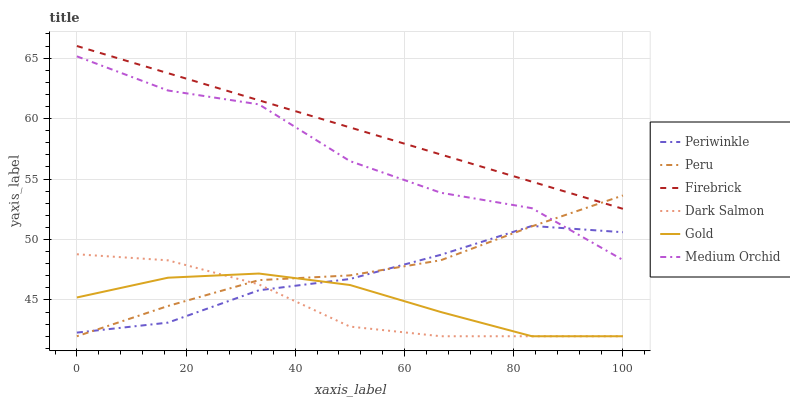Does Dark Salmon have the minimum area under the curve?
Answer yes or no. Yes. Does Firebrick have the maximum area under the curve?
Answer yes or no. Yes. Does Medium Orchid have the minimum area under the curve?
Answer yes or no. No. Does Medium Orchid have the maximum area under the curve?
Answer yes or no. No. Is Firebrick the smoothest?
Answer yes or no. Yes. Is Medium Orchid the roughest?
Answer yes or no. Yes. Is Medium Orchid the smoothest?
Answer yes or no. No. Is Firebrick the roughest?
Answer yes or no. No. Does Gold have the lowest value?
Answer yes or no. Yes. Does Medium Orchid have the lowest value?
Answer yes or no. No. Does Firebrick have the highest value?
Answer yes or no. Yes. Does Medium Orchid have the highest value?
Answer yes or no. No. Is Medium Orchid less than Firebrick?
Answer yes or no. Yes. Is Firebrick greater than Medium Orchid?
Answer yes or no. Yes. Does Gold intersect Periwinkle?
Answer yes or no. Yes. Is Gold less than Periwinkle?
Answer yes or no. No. Is Gold greater than Periwinkle?
Answer yes or no. No. Does Medium Orchid intersect Firebrick?
Answer yes or no. No. 